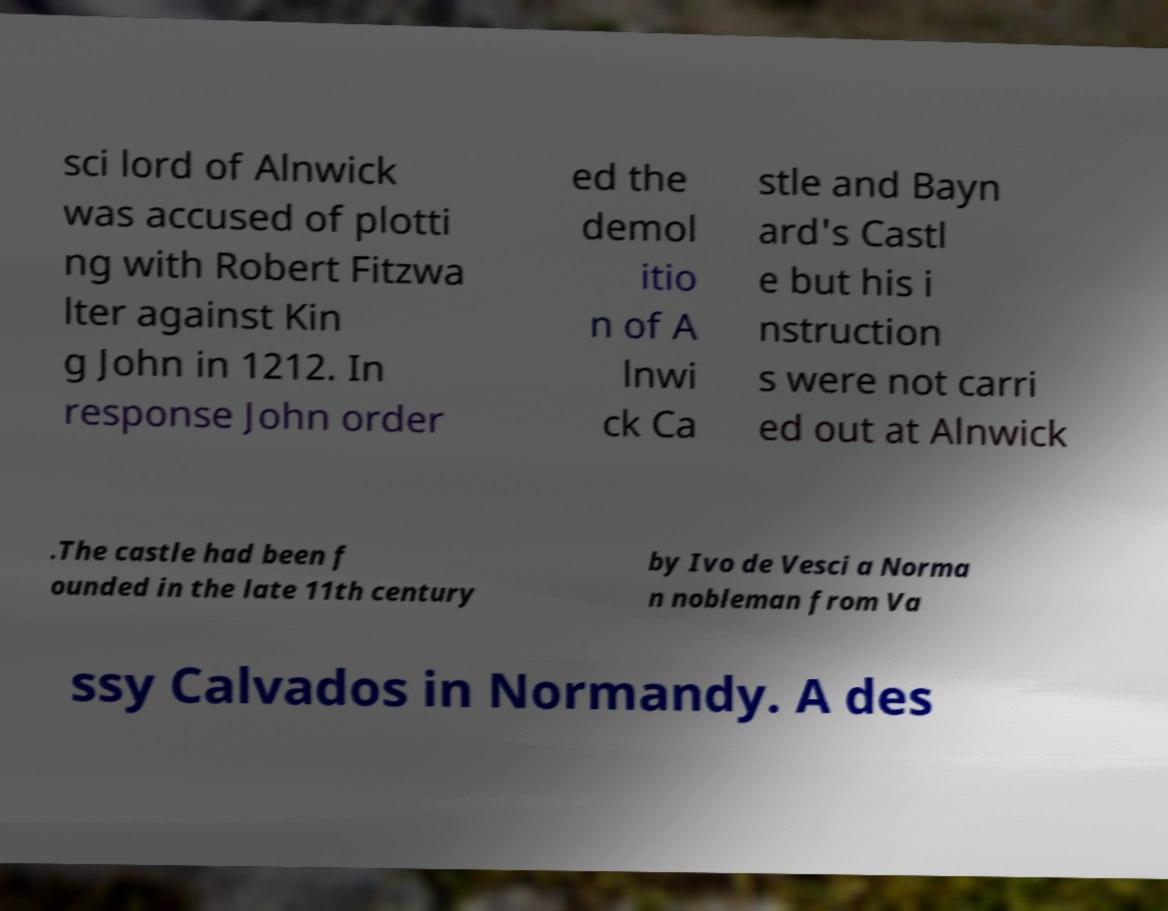Can you accurately transcribe the text from the provided image for me? sci lord of Alnwick was accused of plotti ng with Robert Fitzwa lter against Kin g John in 1212. In response John order ed the demol itio n of A lnwi ck Ca stle and Bayn ard's Castl e but his i nstruction s were not carri ed out at Alnwick .The castle had been f ounded in the late 11th century by Ivo de Vesci a Norma n nobleman from Va ssy Calvados in Normandy. A des 